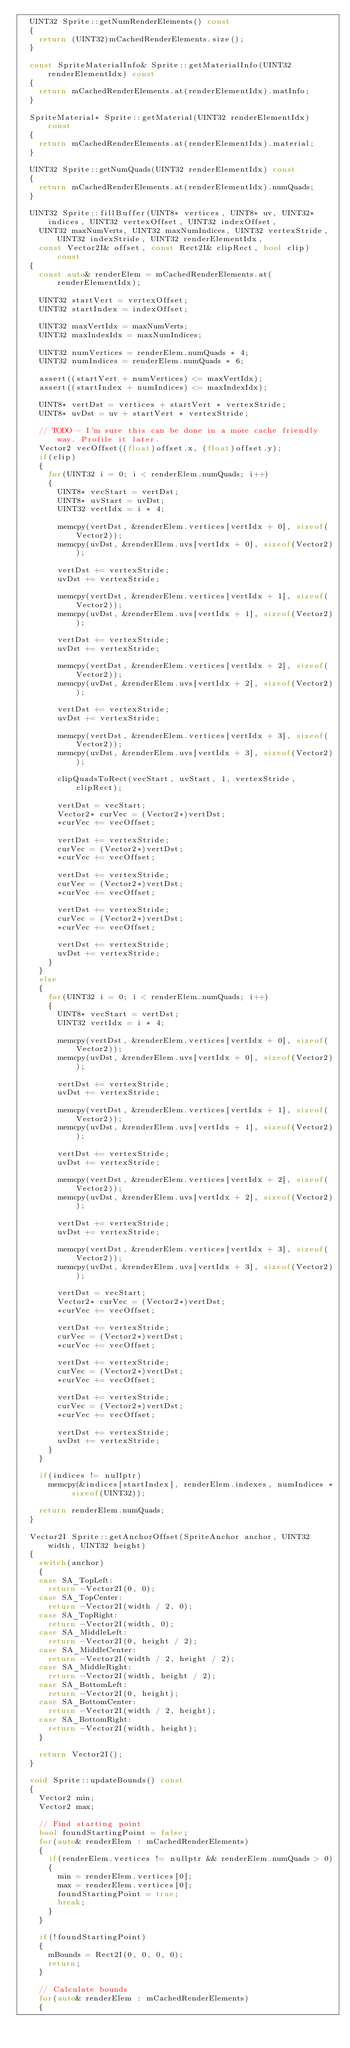Convert code to text. <code><loc_0><loc_0><loc_500><loc_500><_C++_>	UINT32 Sprite::getNumRenderElements() const
	{
		return (UINT32)mCachedRenderElements.size();
	}

	const SpriteMaterialInfo& Sprite::getMaterialInfo(UINT32 renderElementIdx) const
	{
		return mCachedRenderElements.at(renderElementIdx).matInfo;
	}

	SpriteMaterial* Sprite::getMaterial(UINT32 renderElementIdx) const
	{
		return mCachedRenderElements.at(renderElementIdx).material;
	}

	UINT32 Sprite::getNumQuads(UINT32 renderElementIdx) const
	{
		return mCachedRenderElements.at(renderElementIdx).numQuads;
	}

	UINT32 Sprite::fillBuffer(UINT8* vertices, UINT8* uv, UINT32* indices, UINT32 vertexOffset, UINT32 indexOffset,
		UINT32 maxNumVerts, UINT32 maxNumIndices, UINT32 vertexStride, UINT32 indexStride, UINT32 renderElementIdx, 
		const Vector2I& offset, const Rect2I& clipRect, bool clip) const
	{
		const auto& renderElem = mCachedRenderElements.at(renderElementIdx);

		UINT32 startVert = vertexOffset;
		UINT32 startIndex = indexOffset;

		UINT32 maxVertIdx = maxNumVerts;
		UINT32 maxIndexIdx = maxNumIndices;

		UINT32 numVertices = renderElem.numQuads * 4;
		UINT32 numIndices = renderElem.numQuads * 6;

		assert((startVert + numVertices) <= maxVertIdx);
		assert((startIndex + numIndices) <= maxIndexIdx);

		UINT8* vertDst = vertices + startVert * vertexStride;
		UINT8* uvDst = uv + startVert * vertexStride;

		// TODO - I'm sure this can be done in a more cache friendly way. Profile it later.
		Vector2 vecOffset((float)offset.x, (float)offset.y);
		if(clip)
		{
			for(UINT32 i = 0; i < renderElem.numQuads; i++)
			{
				UINT8* vecStart = vertDst;
				UINT8* uvStart = uvDst;
				UINT32 vertIdx = i * 4;

				memcpy(vertDst, &renderElem.vertices[vertIdx + 0], sizeof(Vector2));
				memcpy(uvDst, &renderElem.uvs[vertIdx + 0], sizeof(Vector2));

				vertDst += vertexStride;
				uvDst += vertexStride;

				memcpy(vertDst, &renderElem.vertices[vertIdx + 1], sizeof(Vector2));
				memcpy(uvDst, &renderElem.uvs[vertIdx + 1], sizeof(Vector2));

				vertDst += vertexStride;
				uvDst += vertexStride;

				memcpy(vertDst, &renderElem.vertices[vertIdx + 2], sizeof(Vector2));
				memcpy(uvDst, &renderElem.uvs[vertIdx + 2], sizeof(Vector2));

				vertDst += vertexStride;
				uvDst += vertexStride;

				memcpy(vertDst, &renderElem.vertices[vertIdx + 3], sizeof(Vector2));
				memcpy(uvDst, &renderElem.uvs[vertIdx + 3], sizeof(Vector2));

				clipQuadsToRect(vecStart, uvStart, 1, vertexStride, clipRect);

				vertDst = vecStart;
				Vector2* curVec = (Vector2*)vertDst;
				*curVec += vecOffset;

				vertDst += vertexStride;
				curVec = (Vector2*)vertDst;
				*curVec += vecOffset;

				vertDst += vertexStride;
				curVec = (Vector2*)vertDst;
				*curVec += vecOffset;

				vertDst += vertexStride;
				curVec = (Vector2*)vertDst;
				*curVec += vecOffset;

				vertDst += vertexStride;
				uvDst += vertexStride;
			}
		}
		else
		{
			for(UINT32 i = 0; i < renderElem.numQuads; i++)
			{
				UINT8* vecStart = vertDst;
				UINT32 vertIdx = i * 4;

				memcpy(vertDst, &renderElem.vertices[vertIdx + 0], sizeof(Vector2));
				memcpy(uvDst, &renderElem.uvs[vertIdx + 0], sizeof(Vector2));

				vertDst += vertexStride;
				uvDst += vertexStride;

				memcpy(vertDst, &renderElem.vertices[vertIdx + 1], sizeof(Vector2));
				memcpy(uvDst, &renderElem.uvs[vertIdx + 1], sizeof(Vector2));

				vertDst += vertexStride;
				uvDst += vertexStride;

				memcpy(vertDst, &renderElem.vertices[vertIdx + 2], sizeof(Vector2));
				memcpy(uvDst, &renderElem.uvs[vertIdx + 2], sizeof(Vector2));

				vertDst += vertexStride;
				uvDst += vertexStride;

				memcpy(vertDst, &renderElem.vertices[vertIdx + 3], sizeof(Vector2));
				memcpy(uvDst, &renderElem.uvs[vertIdx + 3], sizeof(Vector2));

				vertDst = vecStart;
				Vector2* curVec = (Vector2*)vertDst;
				*curVec += vecOffset;

				vertDst += vertexStride;
				curVec = (Vector2*)vertDst;
				*curVec += vecOffset;

				vertDst += vertexStride;
				curVec = (Vector2*)vertDst;
				*curVec += vecOffset;

				vertDst += vertexStride;
				curVec = (Vector2*)vertDst;
				*curVec += vecOffset;

				vertDst += vertexStride;
				uvDst += vertexStride;
			}
		}

		if(indices != nullptr)
			memcpy(&indices[startIndex], renderElem.indexes, numIndices * sizeof(UINT32));

		return renderElem.numQuads;
	}

	Vector2I Sprite::getAnchorOffset(SpriteAnchor anchor, UINT32 width, UINT32 height)
	{
		switch(anchor)
		{
		case SA_TopLeft:
			return -Vector2I(0, 0);
		case SA_TopCenter:
			return -Vector2I(width / 2, 0);
		case SA_TopRight:
			return -Vector2I(width, 0);
		case SA_MiddleLeft:
			return -Vector2I(0, height / 2);
		case SA_MiddleCenter:
			return -Vector2I(width / 2, height / 2);
		case SA_MiddleRight:
			return -Vector2I(width, height / 2);
		case SA_BottomLeft:
			return -Vector2I(0, height);
		case SA_BottomCenter:
			return -Vector2I(width / 2, height);
		case SA_BottomRight:
			return -Vector2I(width, height);
		}

		return Vector2I();
	}

	void Sprite::updateBounds() const
	{
		Vector2 min;
		Vector2 max;

		// Find starting point
		bool foundStartingPoint = false;
		for(auto& renderElem : mCachedRenderElements)
		{
			if(renderElem.vertices != nullptr && renderElem.numQuads > 0)
			{
				min = renderElem.vertices[0];
				max = renderElem.vertices[0];
				foundStartingPoint = true;
				break;
			}
		}

		if(!foundStartingPoint)
		{
			mBounds = Rect2I(0, 0, 0, 0);
			return;
		}

		// Calculate bounds
		for(auto& renderElem : mCachedRenderElements)
		{</code> 